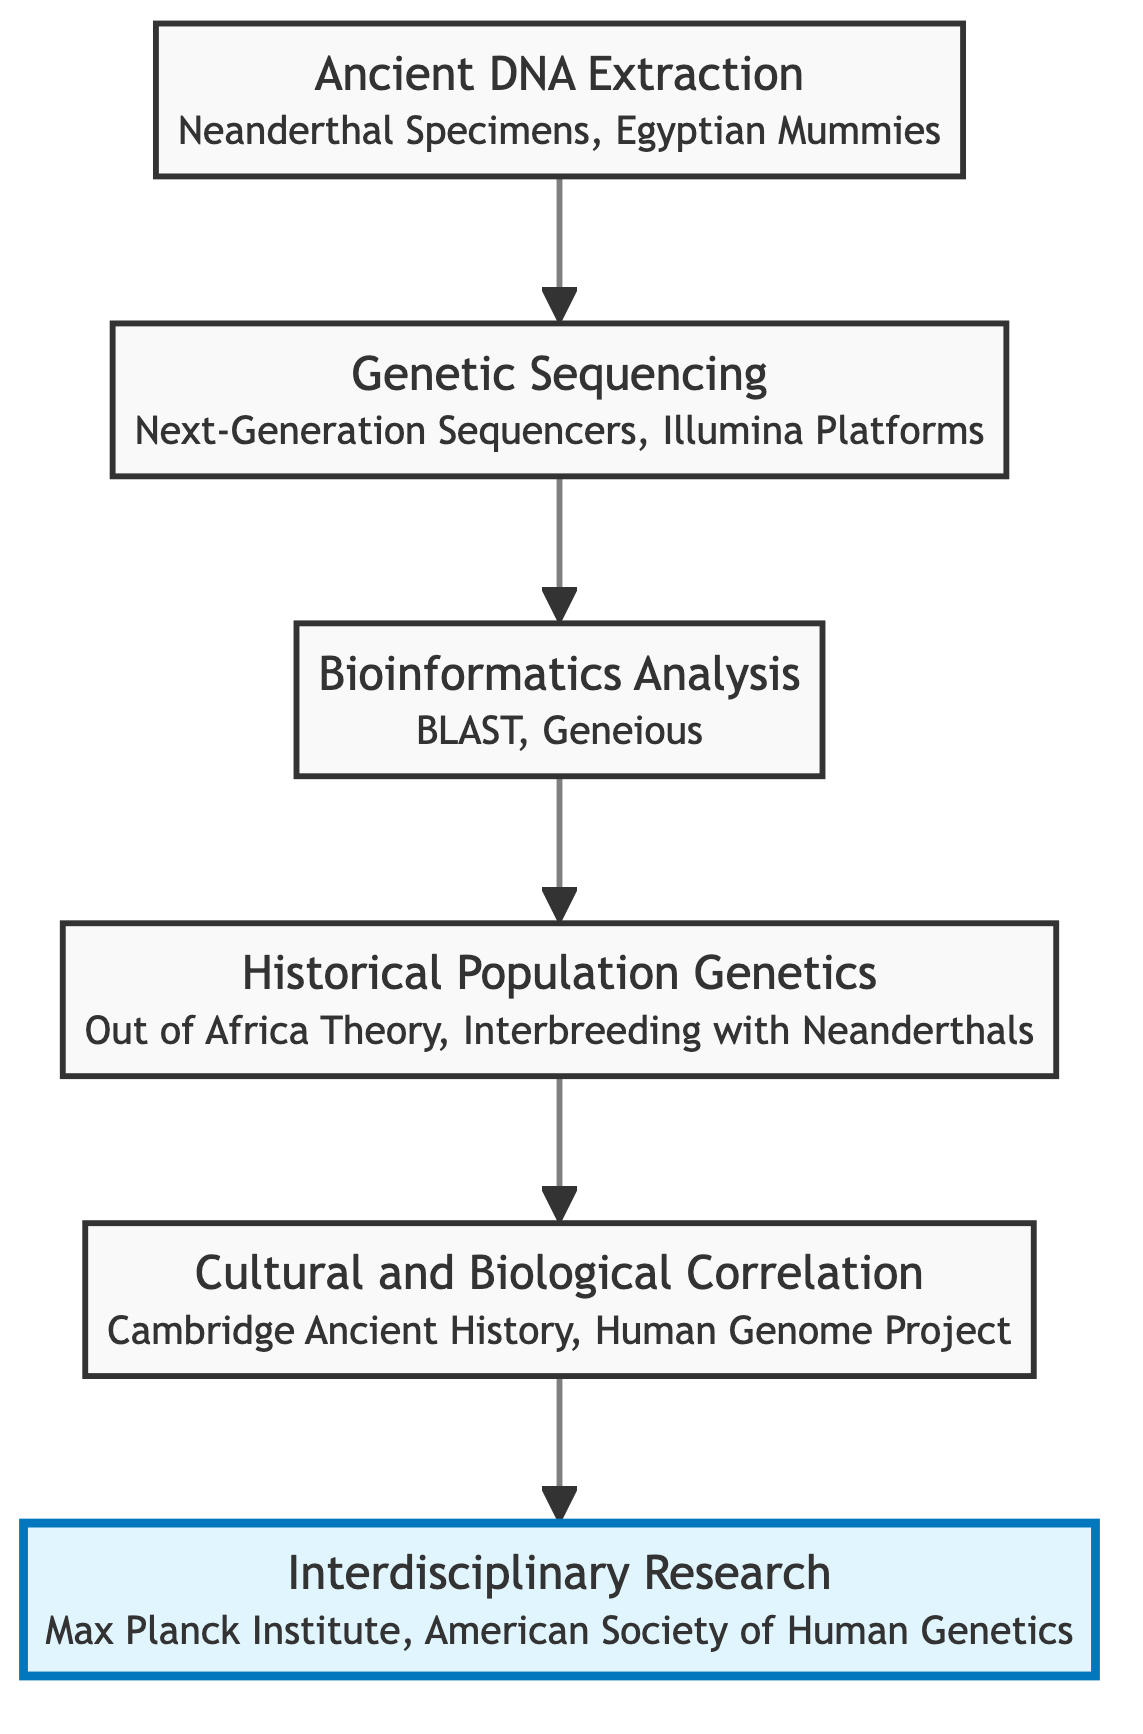What is the first step in the diagram? The first step in the flow chart is "Ancient DNA Extraction". This is determined by the node that appears at the bottom of the flow chart, indicating that it is the initial action taken in the process.
Answer: Ancient DNA Extraction How many nodes are present in the diagram? There are six distinct nodes in the flow chart, each representing a different step in the integration of genetics in archaeological studies. This can be counted by identifying each labeled box in the diagram.
Answer: 6 Which node comes before Bioinformatics Analysis? The node that comes immediately before "Bioinformatics Analysis" is "Genetic Sequencing". This is indicated by the direct arrow leading from "Genetic Sequencing" to "Bioinformatics Analysis" in the flow.
Answer: Genetic Sequencing What is the last step in the integration process shown in the diagram? The last step in the process, positioned at the top of the flow chart, is "Interdisciplinary Research". This can be identified as the final node and is reached after following the sequence of steps from bottom to top.
Answer: Interdisciplinary Research What real-world entities are associated with Cultural and Biological Correlation? The real-world entities associated with "Cultural and Biological Correlation" are "Cambridge Ancient History" and "Human Genome Project". These entities are shown in a small text box beneath the node in the diagram.
Answer: Cambridge Ancient History, Human Genome Project Explain how the flow of the diagram contributes to interdisciplinary research. The flow of the diagram shows that after completing the previous steps, which include extraction, sequencing, analysis, and understanding population genetics and cultural correlation, the next logical step is "Interdisciplinary Research". This indicates that all prior steps culminate in a collaborative effort among different fields, thus highlighting the importance of synergy in the research process.
Answer: Collaboration among disciplines Which process involves studying ancient DNA? The process that involves studying ancient DNA is "Historical Population Genetics". This is shown as a node that follows "Bioinformatics Analysis" in the diagram, indicating it deals directly with the findings from the previous analysis of genetic data.
Answer: Historical Population Genetics What is the primary function of Bioinformatics Analysis? The primary function of "Bioinformatics Analysis" is to process and analyze genetic data using software to identify genetic markers and differences. This is described in the node's text, highlighting its role in the overall process.
Answer: Analyze genetic data How does Genetic Sequencing relate to Ancient DNA Extraction? "Genetic Sequencing" is the direct subsequent step to "Ancient DNA Extraction". This means that after extracting ancient DNA, genetic sequencing is performed to read those sequences, demonstrating a sequential relationship between these two processes.
Answer: Direct subsequent step 